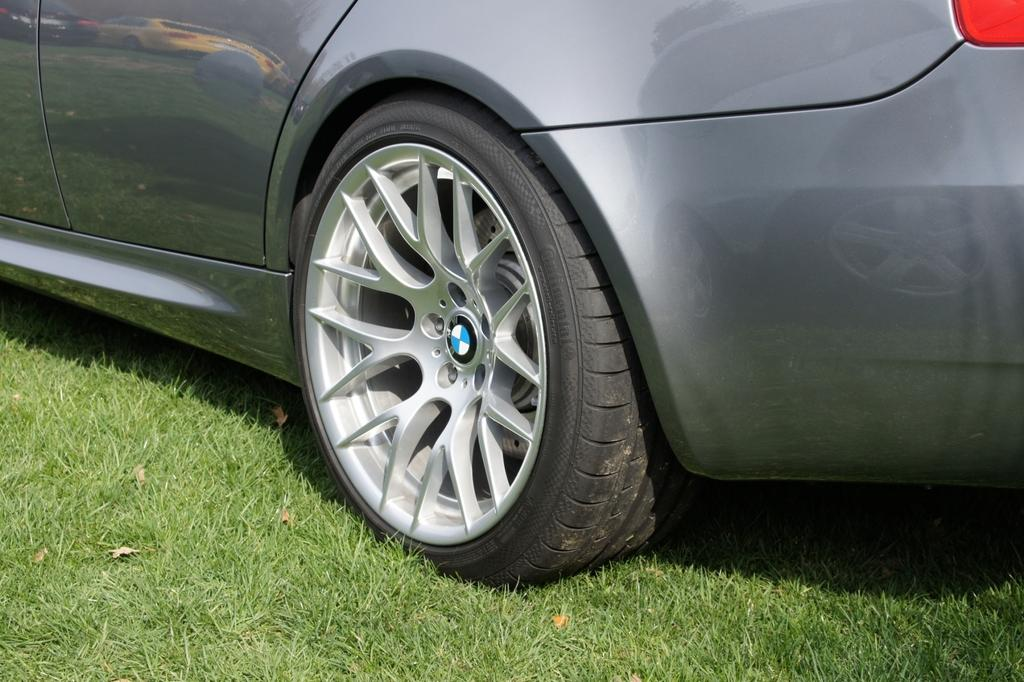What is the main subject of the image? The main subject of the image is a car. Where is the car located in the image? The car is parked on the ground in the image. Reasoning: Let' Let's think step by step in order to produce the conversation. We start by identifying the main subject of the image, which is the car. Then, we describe the car's location, which is on the ground. We avoid yes/no questions and ensure that the language is simple and clear. Absurd Question/Answer: What type of feast is being prepared in the car in the image? There is no feast or any indication of food preparation in the image; it only features a parked car. 